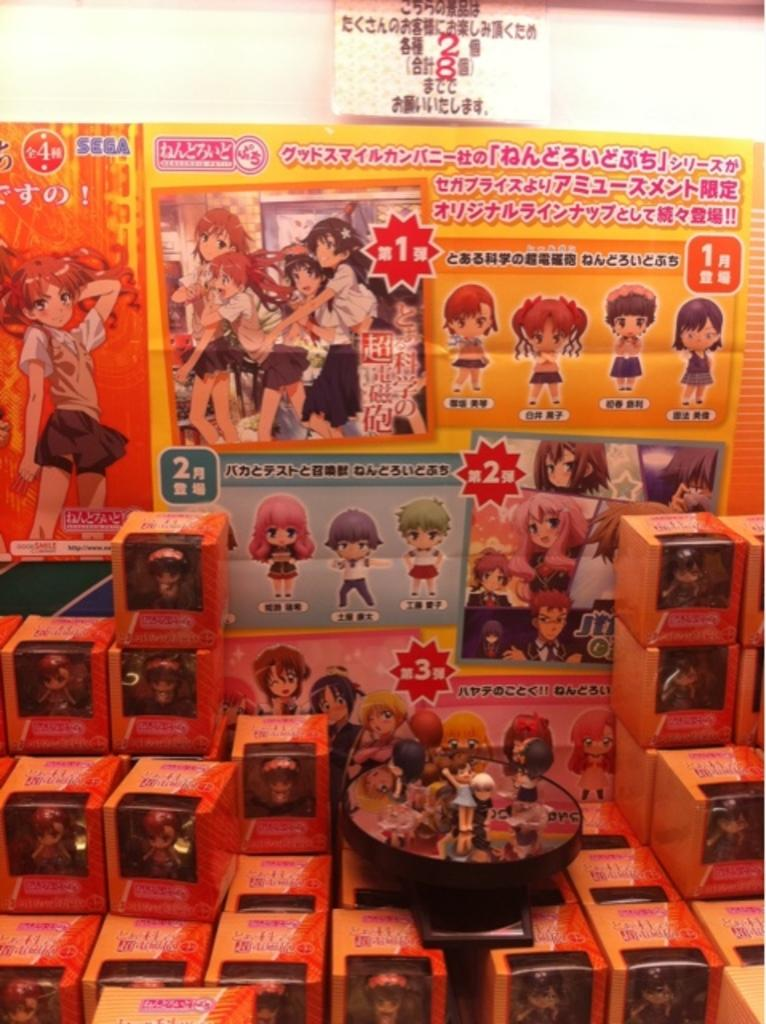What objects are in front of the banner in the image? There are boxes in front of the banner in the image. What can be found at the bottom of the image? There are toys at the bottom of the image. What arithmetic problem is being solved by the kitten in the image? There is no kitten present in the image, and therefore no arithmetic problem being solved. 